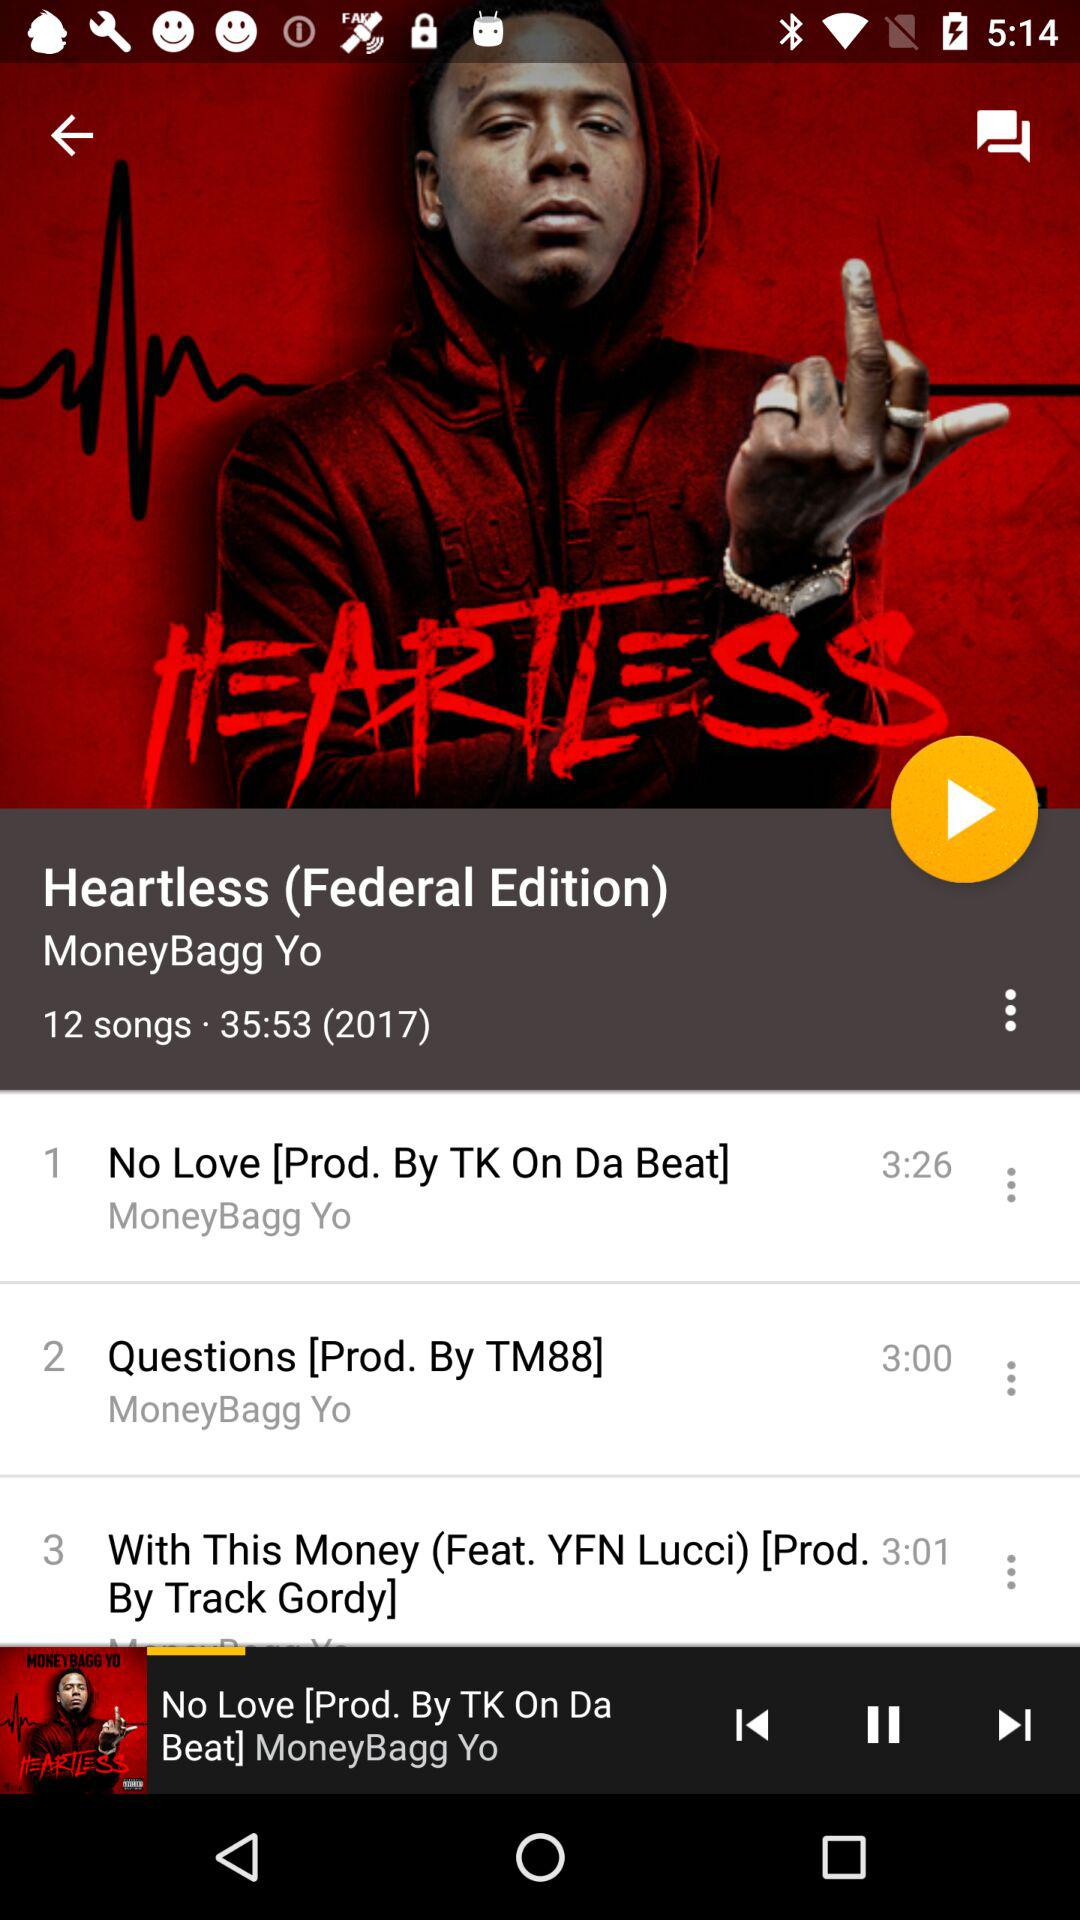Which song is currently playing? The currently playing song is "No Love [Prod. By TK On Da Beat] MoneyBagg Yo". 